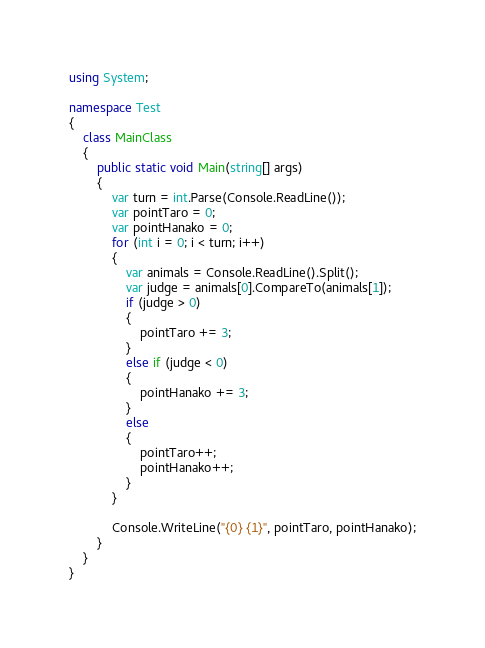Convert code to text. <code><loc_0><loc_0><loc_500><loc_500><_C#_>using System;

namespace Test
{
    class MainClass
    {
        public static void Main(string[] args)
        {
            var turn = int.Parse(Console.ReadLine());
            var pointTaro = 0;
            var pointHanako = 0;
            for (int i = 0; i < turn; i++)
            {
                var animals = Console.ReadLine().Split();
                var judge = animals[0].CompareTo(animals[1]);
                if (judge > 0) 
                {
                    pointTaro += 3;
                }
                else if (judge < 0)
                {
                    pointHanako += 3;
                }
                else
                {
                    pointTaro++;
                    pointHanako++;
                }
            }

            Console.WriteLine("{0} {1}", pointTaro, pointHanako);
        }
    }
}</code> 